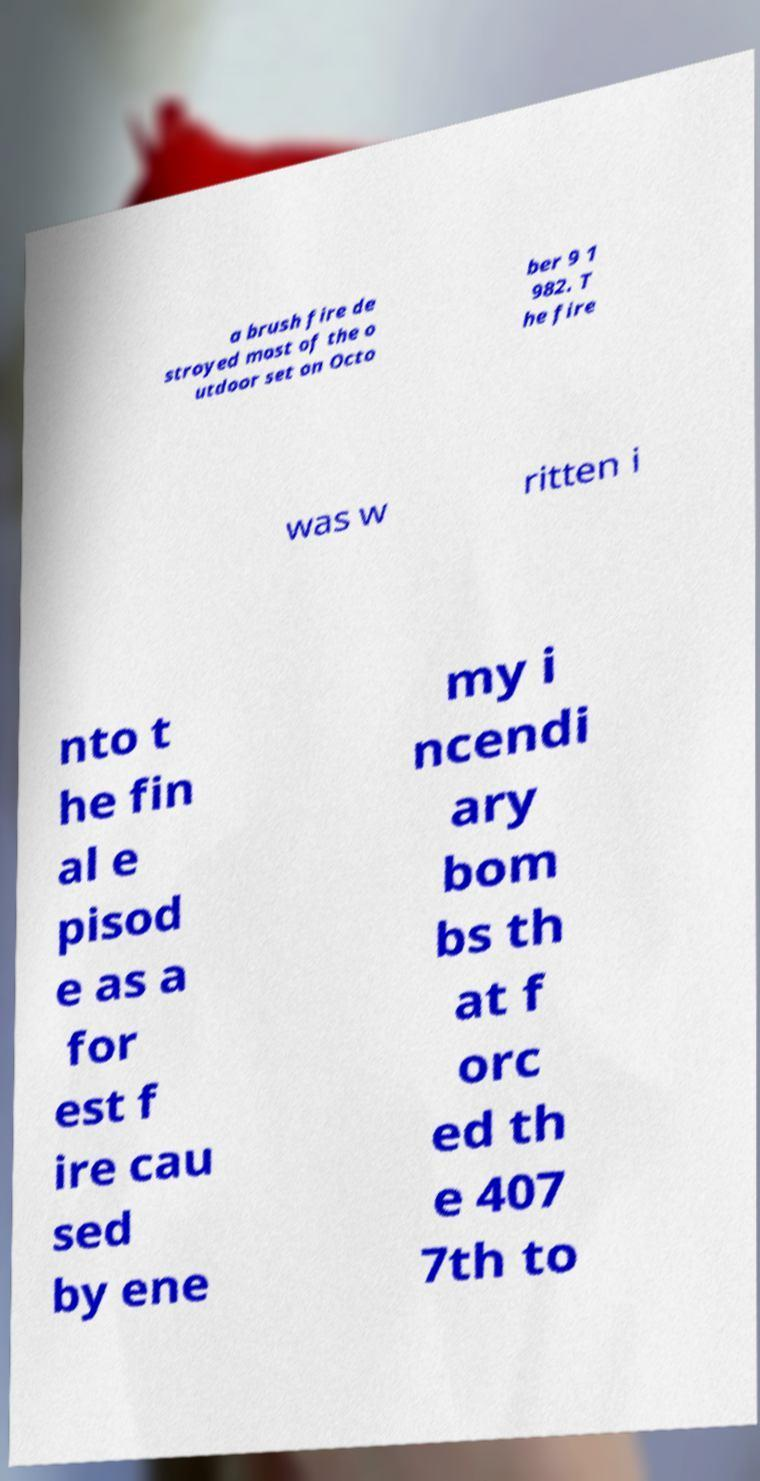Please read and relay the text visible in this image. What does it say? a brush fire de stroyed most of the o utdoor set on Octo ber 9 1 982. T he fire was w ritten i nto t he fin al e pisod e as a for est f ire cau sed by ene my i ncendi ary bom bs th at f orc ed th e 407 7th to 